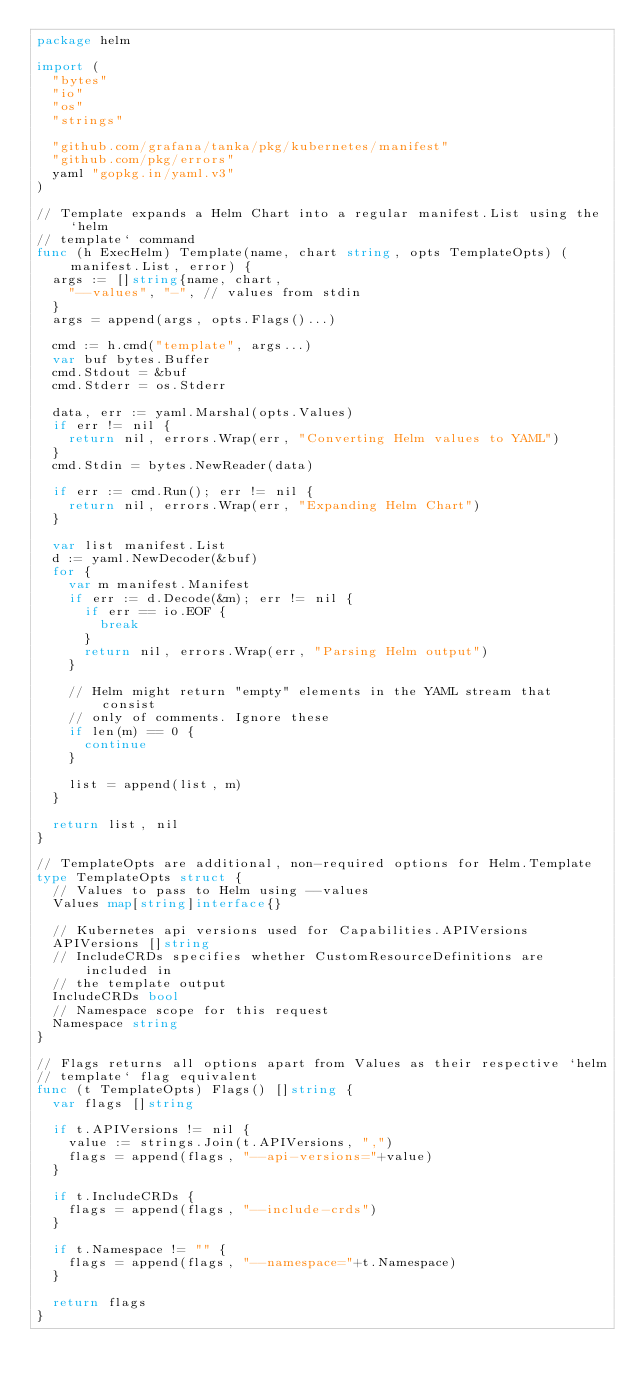<code> <loc_0><loc_0><loc_500><loc_500><_Go_>package helm

import (
	"bytes"
	"io"
	"os"
	"strings"

	"github.com/grafana/tanka/pkg/kubernetes/manifest"
	"github.com/pkg/errors"
	yaml "gopkg.in/yaml.v3"
)

// Template expands a Helm Chart into a regular manifest.List using the `helm
// template` command
func (h ExecHelm) Template(name, chart string, opts TemplateOpts) (manifest.List, error) {
	args := []string{name, chart,
		"--values", "-", // values from stdin
	}
	args = append(args, opts.Flags()...)

	cmd := h.cmd("template", args...)
	var buf bytes.Buffer
	cmd.Stdout = &buf
	cmd.Stderr = os.Stderr

	data, err := yaml.Marshal(opts.Values)
	if err != nil {
		return nil, errors.Wrap(err, "Converting Helm values to YAML")
	}
	cmd.Stdin = bytes.NewReader(data)

	if err := cmd.Run(); err != nil {
		return nil, errors.Wrap(err, "Expanding Helm Chart")
	}

	var list manifest.List
	d := yaml.NewDecoder(&buf)
	for {
		var m manifest.Manifest
		if err := d.Decode(&m); err != nil {
			if err == io.EOF {
				break
			}
			return nil, errors.Wrap(err, "Parsing Helm output")
		}

		// Helm might return "empty" elements in the YAML stream that consist
		// only of comments. Ignore these
		if len(m) == 0 {
			continue
		}

		list = append(list, m)
	}

	return list, nil
}

// TemplateOpts are additional, non-required options for Helm.Template
type TemplateOpts struct {
	// Values to pass to Helm using --values
	Values map[string]interface{}

	// Kubernetes api versions used for Capabilities.APIVersions
	APIVersions []string
	// IncludeCRDs specifies whether CustomResourceDefinitions are included in
	// the template output
	IncludeCRDs bool
	// Namespace scope for this request
	Namespace string
}

// Flags returns all options apart from Values as their respective `helm
// template` flag equivalent
func (t TemplateOpts) Flags() []string {
	var flags []string

	if t.APIVersions != nil {
		value := strings.Join(t.APIVersions, ",")
		flags = append(flags, "--api-versions="+value)
	}

	if t.IncludeCRDs {
		flags = append(flags, "--include-crds")
	}

	if t.Namespace != "" {
		flags = append(flags, "--namespace="+t.Namespace)
	}

	return flags
}
</code> 